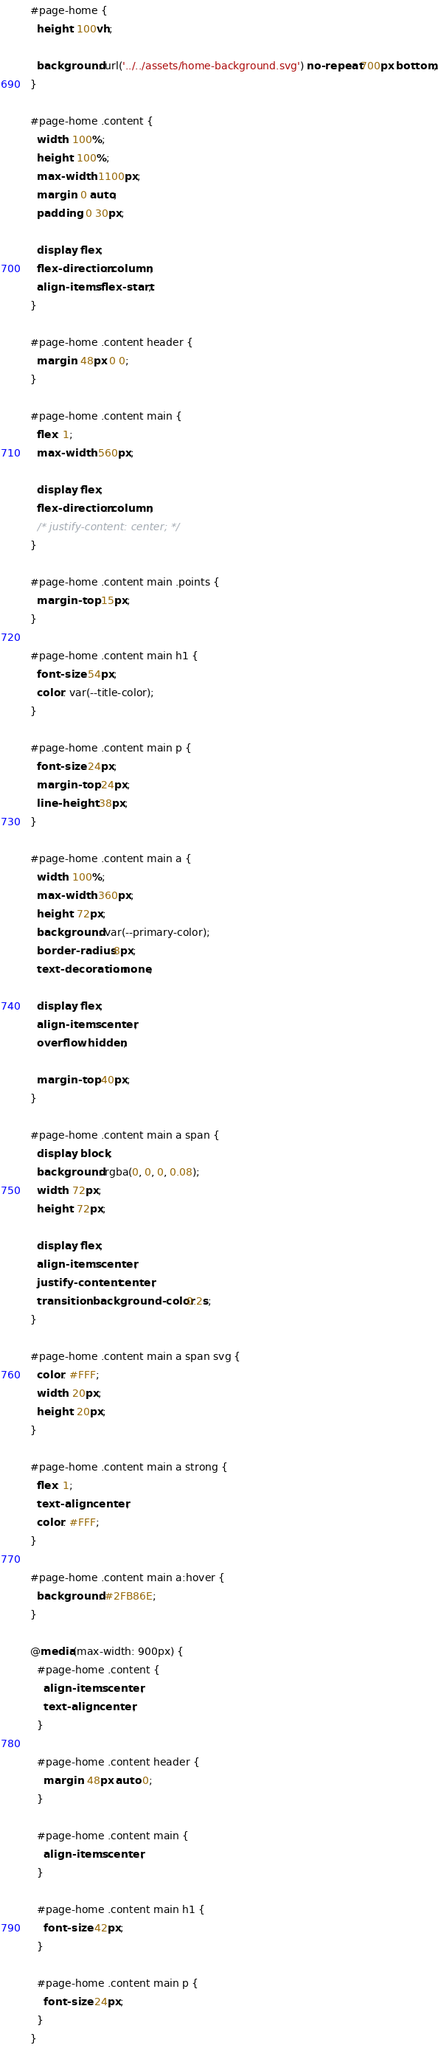<code> <loc_0><loc_0><loc_500><loc_500><_CSS_>#page-home {
  height: 100vh;

  background: url('../../assets/home-background.svg') no-repeat 700px bottom;
}

#page-home .content {
  width: 100%;
  height: 100%;
  max-width: 1100px;
  margin: 0 auto;
  padding: 0 30px;

  display: flex;
  flex-direction: column;
  align-items: flex-start;
}

#page-home .content header {
  margin: 48px 0 0;
}

#page-home .content main {
  flex: 1;
  max-width: 560px;

  display: flex;
  flex-direction: column;
  /* justify-content: center; */
}

#page-home .content main .points {
  margin-top: 15px;
}

#page-home .content main h1 {
  font-size: 54px;
  color: var(--title-color);
}

#page-home .content main p {
  font-size: 24px;
  margin-top: 24px;
  line-height: 38px;
}

#page-home .content main a {
  width: 100%;
  max-width: 360px;
  height: 72px;
  background: var(--primary-color);
  border-radius: 8px;
  text-decoration: none;

  display: flex;
  align-items: center;
  overflow: hidden;

  margin-top: 40px;
}

#page-home .content main a span {
  display: block;
  background: rgba(0, 0, 0, 0.08);
  width: 72px;
  height: 72px;

  display: flex;
  align-items: center;
  justify-content: center;
  transition: background-color 0.2s;
}

#page-home .content main a span svg {
  color: #FFF;
  width: 20px;
  height: 20px;
}

#page-home .content main a strong {
  flex: 1;
  text-align: center;
  color: #FFF;
}

#page-home .content main a:hover {
  background: #2FB86E;
}

@media(max-width: 900px) {
  #page-home .content {
    align-items: center;
    text-align: center;
  }

  #page-home .content header {
    margin: 48px auto 0;
  }

  #page-home .content main {
    align-items: center;
  }

  #page-home .content main h1 {
    font-size: 42px;
  }

  #page-home .content main p {
    font-size: 24px;
  }
}
</code> 